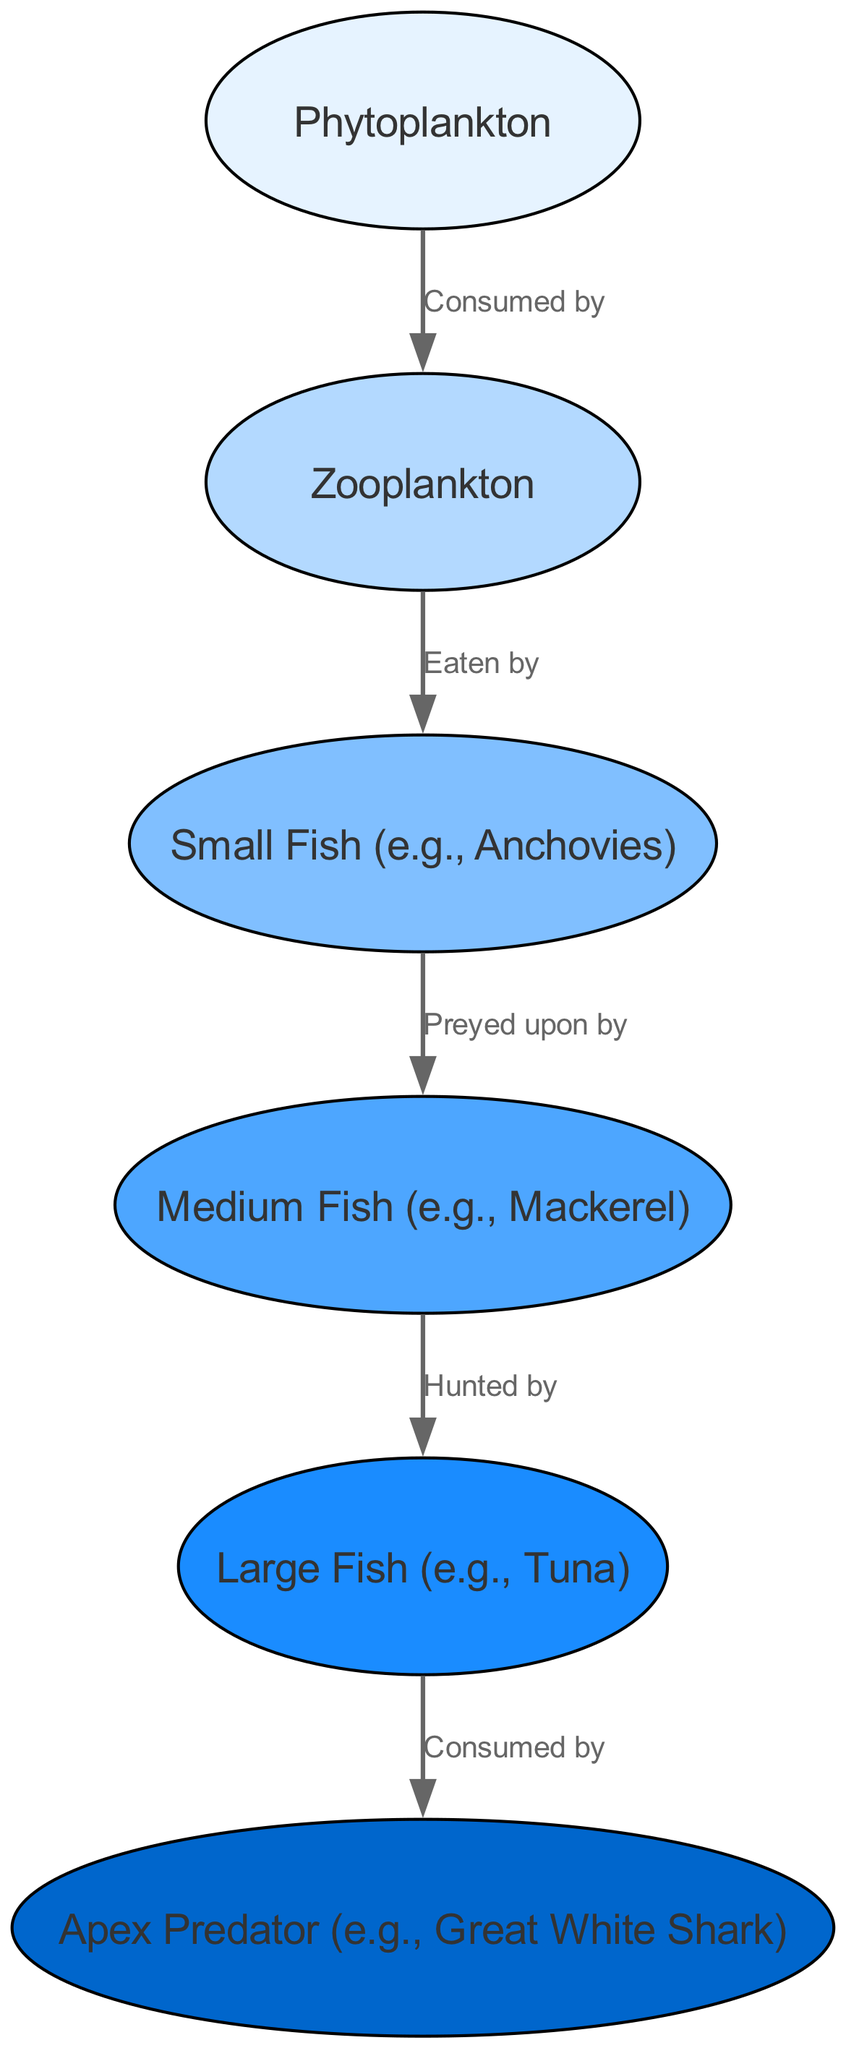What is the first level of the food chain? The diagram shows a hierarchy of elements that forms the food chain, where "Phytoplankton" is labeled as level 1, indicating it is the foundational primary producer in this marine ecosystem.
Answer: Phytoplankton How many nodes are in the diagram? The diagram contains a total of 6 unique ecological roles represented as nodes, including Phytoplankton, Zooplankton, Small Fish, Medium Fish, Large Fish, and Apex Predator.
Answer: 6 What are the apex predators in the ocean according to the diagram? The diagram specifies "Apex Predator" and provides the example "Great White Shark," indicating this is the top of the food chain, consuming the largest fish.
Answer: Apex Predator Who consumes the large fish? According to the visual relationships in the diagram, the "Large Fish" is indicated to be consumed by the "Apex Predator," which is the next tier in the food chain hierarchy.
Answer: Apex Predator What type of organism is directly eaten by small fish? The diagram illustrates that "Zooplankton" is directly eaten by "Small Fish," indicating the role of small fish as consumers at the second tier.
Answer: Zooplankton What is the relationship between medium fish and large fish? The diagram depicts that "Medium Fish" prey upon "Large Fish," indicating a predation relationship where medium fish hunt larger species.
Answer: Preyed upon by How many layers are in the food chain? By analyzing the levels indicated in the diagram, there are 6 distinct layers, starting from the primary producer to the apex predators, comprising Phytoplankton to Apex Predator.
Answer: 6 Which organism feeds on zooplankton? The diagram shows that "Zooplankton" is specifically eaten by "Small Fish," establishing a direct feeding relationship within the marine ecosystem’s food chain.
Answer: Small Fish What level is represented by the medium fish in the diagram? The diagram assigns "Medium Fish" to level 4, placing it as the fourth step in the food chain, illustrating its position above the smaller fish and below the large fish.
Answer: Level 4 